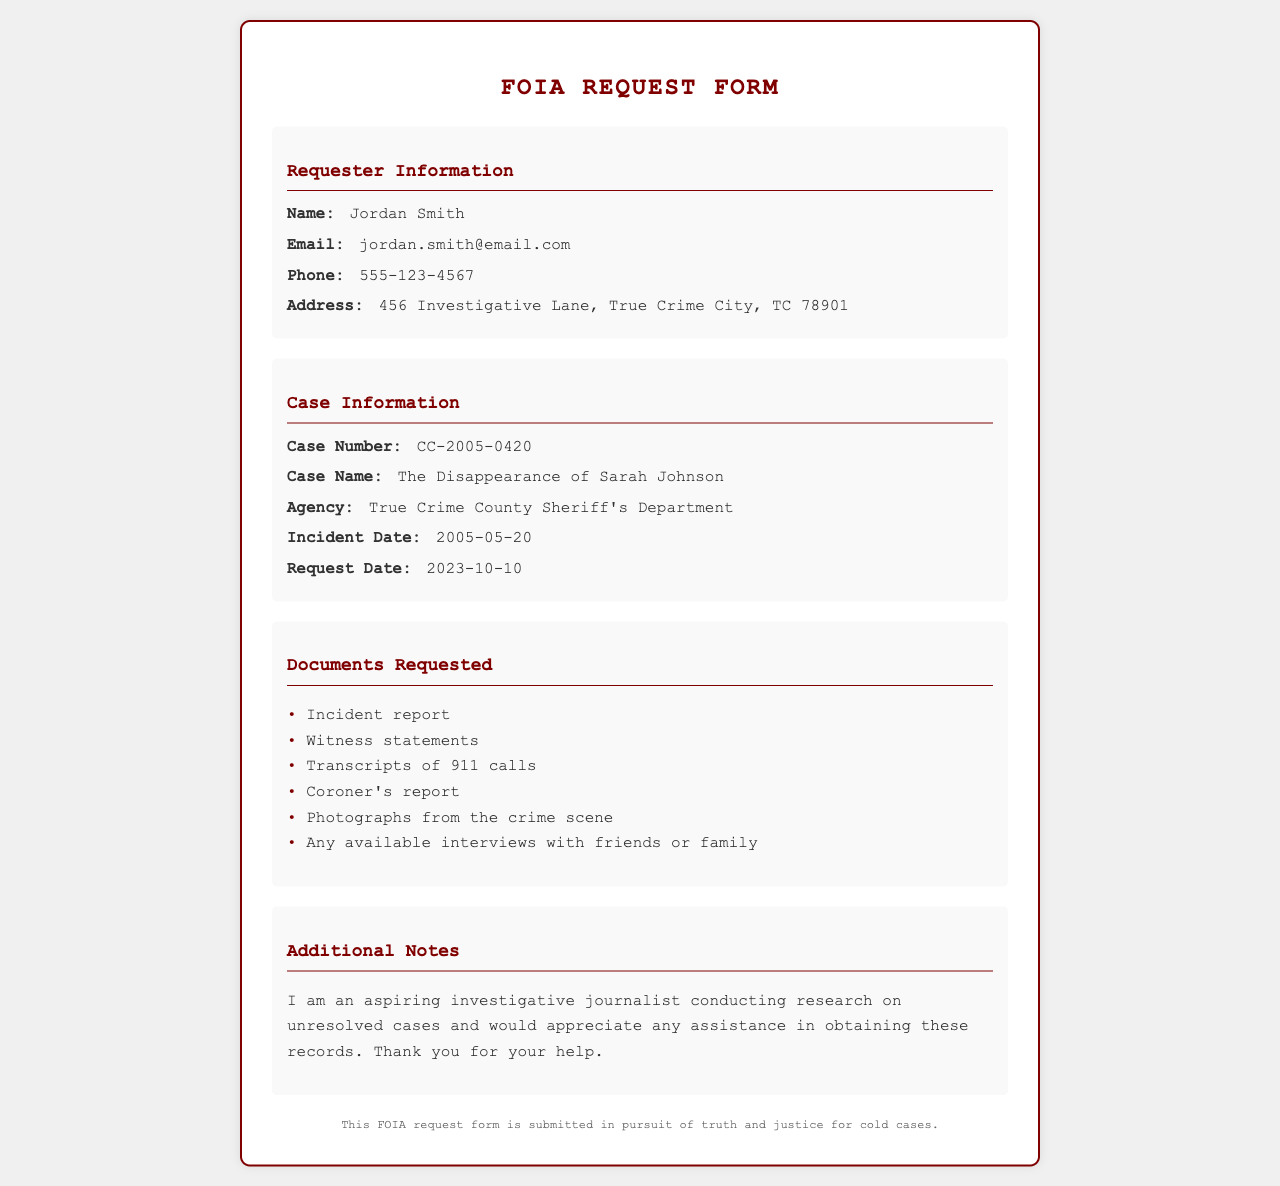what is the requester's name? The name of the requester is provided in the information section, which is Jordan Smith.
Answer: Jordan Smith what is the incident date of the case? The incident date for the case is stated in the case information section, which lists it as 2005-05-20.
Answer: 2005-05-20 what is the case number? The case number is explicitly mentioned in the case information, indicated as CC-2005-0420.
Answer: CC-2005-0420 which agency is handling the case? The agency responsible for the case is specified in the case information section as True Crime County Sheriff's Department.
Answer: True Crime County Sheriff's Department how many types of documents are requested? The documents requested are listed, and there are a total of six types mentioned in the document.
Answer: 6 why is the requester seeking these documents? The additional notes section of the document specifies that the requester is conducting research on unresolved cases.
Answer: Conducting research on unresolved cases when was the request made? The date of the request is listed under case information as 2023-10-10.
Answer: 2023-10-10 what type of report is included in the document request? One of the requested documents is an incident report, which is explicitly mentioned in the list of documents requested.
Answer: Incident report 